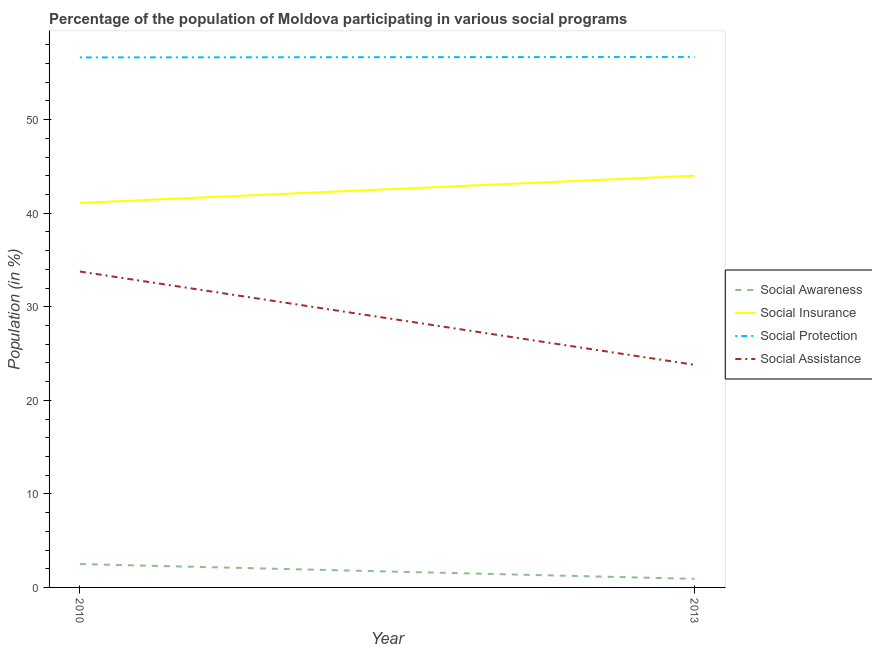How many different coloured lines are there?
Make the answer very short. 4. Does the line corresponding to participation of population in social protection programs intersect with the line corresponding to participation of population in social assistance programs?
Provide a short and direct response. No. What is the participation of population in social insurance programs in 2013?
Provide a succinct answer. 44.01. Across all years, what is the maximum participation of population in social insurance programs?
Your answer should be very brief. 44.01. Across all years, what is the minimum participation of population in social protection programs?
Your answer should be compact. 56.65. In which year was the participation of population in social insurance programs maximum?
Offer a very short reply. 2013. In which year was the participation of population in social assistance programs minimum?
Offer a very short reply. 2013. What is the total participation of population in social assistance programs in the graph?
Your answer should be very brief. 57.56. What is the difference between the participation of population in social insurance programs in 2010 and that in 2013?
Ensure brevity in your answer.  -2.91. What is the difference between the participation of population in social assistance programs in 2013 and the participation of population in social protection programs in 2010?
Offer a terse response. -32.85. What is the average participation of population in social protection programs per year?
Ensure brevity in your answer.  56.67. In the year 2010, what is the difference between the participation of population in social insurance programs and participation of population in social awareness programs?
Ensure brevity in your answer.  38.6. In how many years, is the participation of population in social insurance programs greater than 10 %?
Keep it short and to the point. 2. What is the ratio of the participation of population in social awareness programs in 2010 to that in 2013?
Offer a terse response. 2.73. Is the participation of population in social assistance programs in 2010 less than that in 2013?
Your response must be concise. No. In how many years, is the participation of population in social awareness programs greater than the average participation of population in social awareness programs taken over all years?
Your answer should be very brief. 1. Is it the case that in every year, the sum of the participation of population in social protection programs and participation of population in social awareness programs is greater than the sum of participation of population in social insurance programs and participation of population in social assistance programs?
Offer a very short reply. No. Is it the case that in every year, the sum of the participation of population in social awareness programs and participation of population in social insurance programs is greater than the participation of population in social protection programs?
Ensure brevity in your answer.  No. Is the participation of population in social protection programs strictly less than the participation of population in social assistance programs over the years?
Keep it short and to the point. No. What is the difference between two consecutive major ticks on the Y-axis?
Give a very brief answer. 10. Are the values on the major ticks of Y-axis written in scientific E-notation?
Your answer should be compact. No. How many legend labels are there?
Offer a very short reply. 4. What is the title of the graph?
Keep it short and to the point. Percentage of the population of Moldova participating in various social programs . Does "Ease of arranging shipments" appear as one of the legend labels in the graph?
Make the answer very short. No. What is the label or title of the X-axis?
Ensure brevity in your answer.  Year. What is the Population (in %) in Social Awareness in 2010?
Offer a terse response. 2.5. What is the Population (in %) in Social Insurance in 2010?
Your response must be concise. 41.1. What is the Population (in %) of Social Protection in 2010?
Your answer should be very brief. 56.65. What is the Population (in %) in Social Assistance in 2010?
Keep it short and to the point. 33.76. What is the Population (in %) of Social Awareness in 2013?
Offer a very short reply. 0.92. What is the Population (in %) of Social Insurance in 2013?
Make the answer very short. 44.01. What is the Population (in %) of Social Protection in 2013?
Make the answer very short. 56.7. What is the Population (in %) in Social Assistance in 2013?
Your answer should be very brief. 23.79. Across all years, what is the maximum Population (in %) in Social Awareness?
Offer a terse response. 2.5. Across all years, what is the maximum Population (in %) of Social Insurance?
Provide a short and direct response. 44.01. Across all years, what is the maximum Population (in %) in Social Protection?
Your response must be concise. 56.7. Across all years, what is the maximum Population (in %) in Social Assistance?
Keep it short and to the point. 33.76. Across all years, what is the minimum Population (in %) in Social Awareness?
Offer a terse response. 0.92. Across all years, what is the minimum Population (in %) in Social Insurance?
Your answer should be compact. 41.1. Across all years, what is the minimum Population (in %) of Social Protection?
Offer a terse response. 56.65. Across all years, what is the minimum Population (in %) in Social Assistance?
Make the answer very short. 23.79. What is the total Population (in %) in Social Awareness in the graph?
Your response must be concise. 3.41. What is the total Population (in %) in Social Insurance in the graph?
Give a very brief answer. 85.1. What is the total Population (in %) in Social Protection in the graph?
Provide a succinct answer. 113.35. What is the total Population (in %) in Social Assistance in the graph?
Make the answer very short. 57.56. What is the difference between the Population (in %) of Social Awareness in 2010 and that in 2013?
Your answer should be compact. 1.58. What is the difference between the Population (in %) of Social Insurance in 2010 and that in 2013?
Give a very brief answer. -2.91. What is the difference between the Population (in %) in Social Protection in 2010 and that in 2013?
Your answer should be very brief. -0.05. What is the difference between the Population (in %) of Social Assistance in 2010 and that in 2013?
Offer a very short reply. 9.97. What is the difference between the Population (in %) of Social Awareness in 2010 and the Population (in %) of Social Insurance in 2013?
Your answer should be compact. -41.51. What is the difference between the Population (in %) in Social Awareness in 2010 and the Population (in %) in Social Protection in 2013?
Keep it short and to the point. -54.2. What is the difference between the Population (in %) in Social Awareness in 2010 and the Population (in %) in Social Assistance in 2013?
Keep it short and to the point. -21.3. What is the difference between the Population (in %) of Social Insurance in 2010 and the Population (in %) of Social Protection in 2013?
Provide a succinct answer. -15.6. What is the difference between the Population (in %) of Social Insurance in 2010 and the Population (in %) of Social Assistance in 2013?
Provide a succinct answer. 17.31. What is the difference between the Population (in %) in Social Protection in 2010 and the Population (in %) in Social Assistance in 2013?
Provide a short and direct response. 32.85. What is the average Population (in %) in Social Awareness per year?
Offer a very short reply. 1.71. What is the average Population (in %) in Social Insurance per year?
Give a very brief answer. 42.55. What is the average Population (in %) of Social Protection per year?
Offer a terse response. 56.67. What is the average Population (in %) of Social Assistance per year?
Your answer should be very brief. 28.78. In the year 2010, what is the difference between the Population (in %) of Social Awareness and Population (in %) of Social Insurance?
Keep it short and to the point. -38.6. In the year 2010, what is the difference between the Population (in %) of Social Awareness and Population (in %) of Social Protection?
Make the answer very short. -54.15. In the year 2010, what is the difference between the Population (in %) of Social Awareness and Population (in %) of Social Assistance?
Your answer should be compact. -31.27. In the year 2010, what is the difference between the Population (in %) in Social Insurance and Population (in %) in Social Protection?
Your answer should be very brief. -15.55. In the year 2010, what is the difference between the Population (in %) in Social Insurance and Population (in %) in Social Assistance?
Make the answer very short. 7.33. In the year 2010, what is the difference between the Population (in %) in Social Protection and Population (in %) in Social Assistance?
Provide a succinct answer. 22.88. In the year 2013, what is the difference between the Population (in %) of Social Awareness and Population (in %) of Social Insurance?
Offer a very short reply. -43.09. In the year 2013, what is the difference between the Population (in %) of Social Awareness and Population (in %) of Social Protection?
Keep it short and to the point. -55.78. In the year 2013, what is the difference between the Population (in %) in Social Awareness and Population (in %) in Social Assistance?
Ensure brevity in your answer.  -22.88. In the year 2013, what is the difference between the Population (in %) of Social Insurance and Population (in %) of Social Protection?
Your answer should be very brief. -12.69. In the year 2013, what is the difference between the Population (in %) of Social Insurance and Population (in %) of Social Assistance?
Your response must be concise. 20.21. In the year 2013, what is the difference between the Population (in %) of Social Protection and Population (in %) of Social Assistance?
Provide a short and direct response. 32.91. What is the ratio of the Population (in %) in Social Awareness in 2010 to that in 2013?
Your response must be concise. 2.73. What is the ratio of the Population (in %) of Social Insurance in 2010 to that in 2013?
Offer a terse response. 0.93. What is the ratio of the Population (in %) in Social Assistance in 2010 to that in 2013?
Your response must be concise. 1.42. What is the difference between the highest and the second highest Population (in %) in Social Awareness?
Offer a terse response. 1.58. What is the difference between the highest and the second highest Population (in %) of Social Insurance?
Offer a terse response. 2.91. What is the difference between the highest and the second highest Population (in %) of Social Protection?
Offer a very short reply. 0.05. What is the difference between the highest and the second highest Population (in %) in Social Assistance?
Keep it short and to the point. 9.97. What is the difference between the highest and the lowest Population (in %) in Social Awareness?
Provide a succinct answer. 1.58. What is the difference between the highest and the lowest Population (in %) of Social Insurance?
Give a very brief answer. 2.91. What is the difference between the highest and the lowest Population (in %) of Social Protection?
Make the answer very short. 0.05. What is the difference between the highest and the lowest Population (in %) in Social Assistance?
Your answer should be very brief. 9.97. 